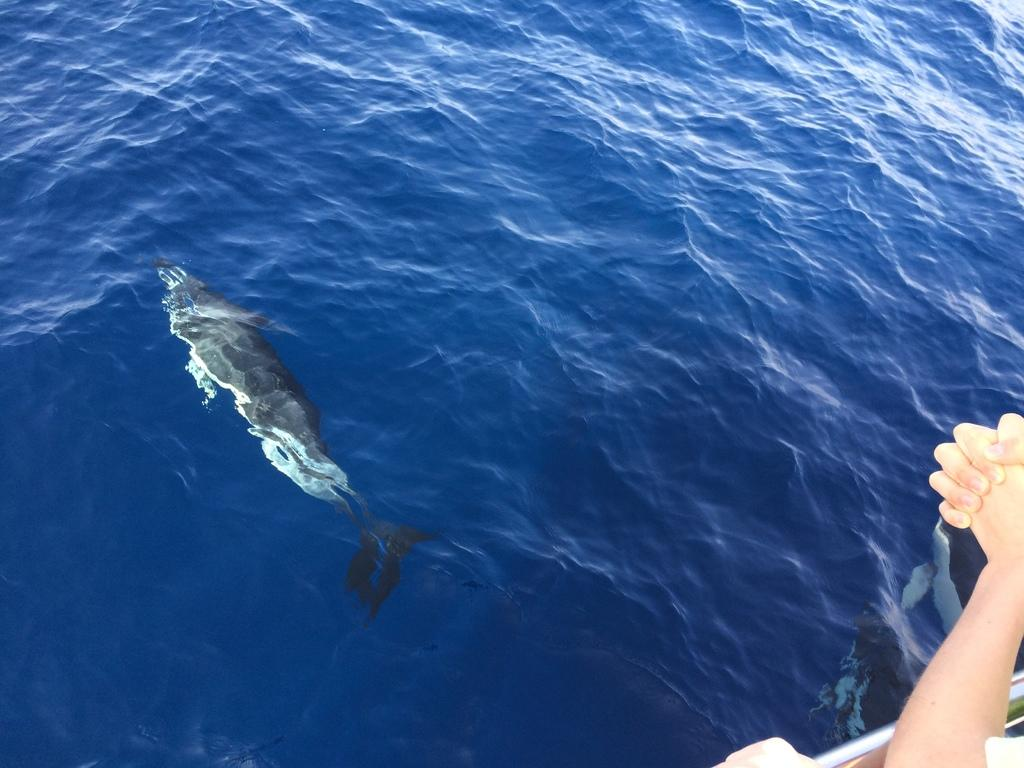What is in the water in the image? There is a fish in the water in the image. Who or what else can be seen in the image? There is a man on the right side of the image. What type of jeans is the fish wearing in the image? There is no fish wearing jeans in the image, as fish do not wear clothing. 